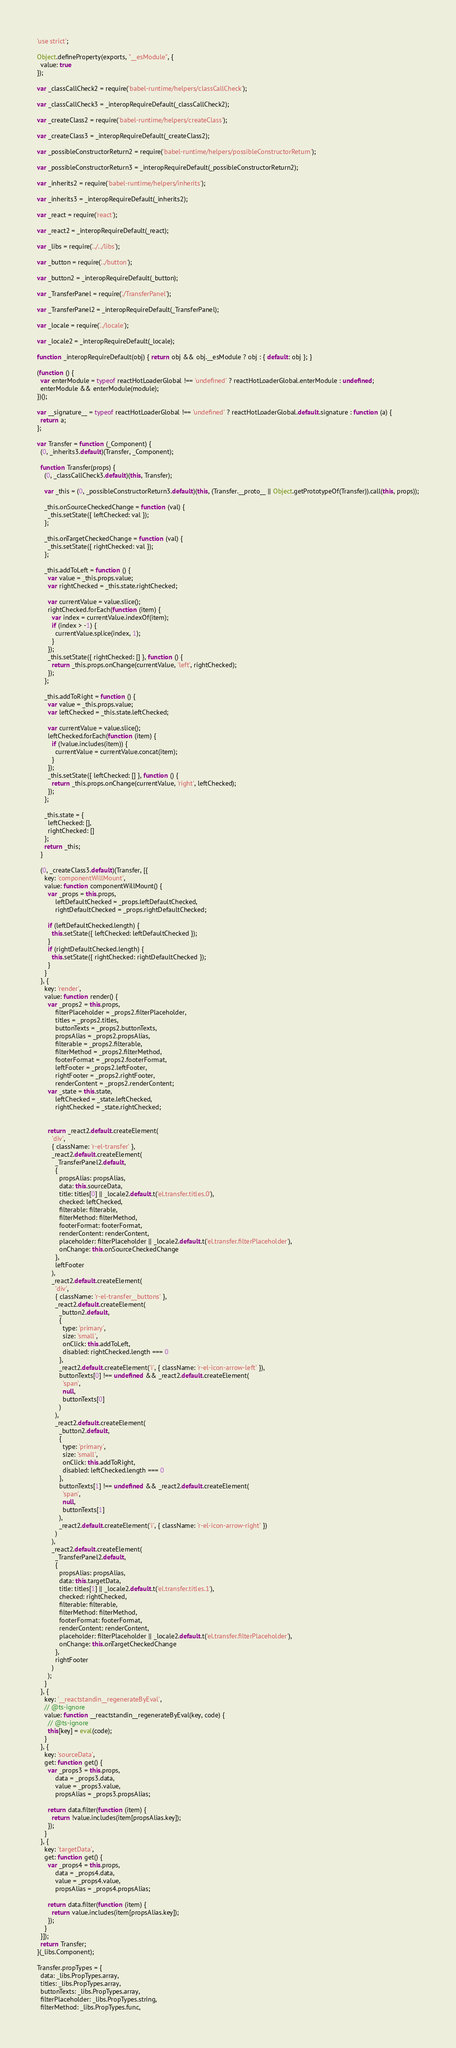<code> <loc_0><loc_0><loc_500><loc_500><_JavaScript_>'use strict';

Object.defineProperty(exports, "__esModule", {
  value: true
});

var _classCallCheck2 = require('babel-runtime/helpers/classCallCheck');

var _classCallCheck3 = _interopRequireDefault(_classCallCheck2);

var _createClass2 = require('babel-runtime/helpers/createClass');

var _createClass3 = _interopRequireDefault(_createClass2);

var _possibleConstructorReturn2 = require('babel-runtime/helpers/possibleConstructorReturn');

var _possibleConstructorReturn3 = _interopRequireDefault(_possibleConstructorReturn2);

var _inherits2 = require('babel-runtime/helpers/inherits');

var _inherits3 = _interopRequireDefault(_inherits2);

var _react = require('react');

var _react2 = _interopRequireDefault(_react);

var _libs = require('../../libs');

var _button = require('../button');

var _button2 = _interopRequireDefault(_button);

var _TransferPanel = require('./TransferPanel');

var _TransferPanel2 = _interopRequireDefault(_TransferPanel);

var _locale = require('../locale');

var _locale2 = _interopRequireDefault(_locale);

function _interopRequireDefault(obj) { return obj && obj.__esModule ? obj : { default: obj }; }

(function () {
  var enterModule = typeof reactHotLoaderGlobal !== 'undefined' ? reactHotLoaderGlobal.enterModule : undefined;
  enterModule && enterModule(module);
})();

var __signature__ = typeof reactHotLoaderGlobal !== 'undefined' ? reactHotLoaderGlobal.default.signature : function (a) {
  return a;
};

var Transfer = function (_Component) {
  (0, _inherits3.default)(Transfer, _Component);

  function Transfer(props) {
    (0, _classCallCheck3.default)(this, Transfer);

    var _this = (0, _possibleConstructorReturn3.default)(this, (Transfer.__proto__ || Object.getPrototypeOf(Transfer)).call(this, props));

    _this.onSourceCheckedChange = function (val) {
      _this.setState({ leftChecked: val });
    };

    _this.onTargetCheckedChange = function (val) {
      _this.setState({ rightChecked: val });
    };

    _this.addToLeft = function () {
      var value = _this.props.value;
      var rightChecked = _this.state.rightChecked;

      var currentValue = value.slice();
      rightChecked.forEach(function (item) {
        var index = currentValue.indexOf(item);
        if (index > -1) {
          currentValue.splice(index, 1);
        }
      });
      _this.setState({ rightChecked: [] }, function () {
        return _this.props.onChange(currentValue, 'left', rightChecked);
      });
    };

    _this.addToRight = function () {
      var value = _this.props.value;
      var leftChecked = _this.state.leftChecked;

      var currentValue = value.slice();
      leftChecked.forEach(function (item) {
        if (!value.includes(item)) {
          currentValue = currentValue.concat(item);
        }
      });
      _this.setState({ leftChecked: [] }, function () {
        return _this.props.onChange(currentValue, 'right', leftChecked);
      });
    };

    _this.state = {
      leftChecked: [],
      rightChecked: []
    };
    return _this;
  }

  (0, _createClass3.default)(Transfer, [{
    key: 'componentWillMount',
    value: function componentWillMount() {
      var _props = this.props,
          leftDefaultChecked = _props.leftDefaultChecked,
          rightDefaultChecked = _props.rightDefaultChecked;

      if (leftDefaultChecked.length) {
        this.setState({ leftChecked: leftDefaultChecked });
      }
      if (rightDefaultChecked.length) {
        this.setState({ rightChecked: rightDefaultChecked });
      }
    }
  }, {
    key: 'render',
    value: function render() {
      var _props2 = this.props,
          filterPlaceholder = _props2.filterPlaceholder,
          titles = _props2.titles,
          buttonTexts = _props2.buttonTexts,
          propsAlias = _props2.propsAlias,
          filterable = _props2.filterable,
          filterMethod = _props2.filterMethod,
          footerFormat = _props2.footerFormat,
          leftFooter = _props2.leftFooter,
          rightFooter = _props2.rightFooter,
          renderContent = _props2.renderContent;
      var _state = this.state,
          leftChecked = _state.leftChecked,
          rightChecked = _state.rightChecked;


      return _react2.default.createElement(
        'div',
        { className: 'r-el-transfer' },
        _react2.default.createElement(
          _TransferPanel2.default,
          {
            propsAlias: propsAlias,
            data: this.sourceData,
            title: titles[0] || _locale2.default.t('el.transfer.titles.0'),
            checked: leftChecked,
            filterable: filterable,
            filterMethod: filterMethod,
            footerFormat: footerFormat,
            renderContent: renderContent,
            placeholder: filterPlaceholder || _locale2.default.t('el.transfer.filterPlaceholder'),
            onChange: this.onSourceCheckedChange
          },
          leftFooter
        ),
        _react2.default.createElement(
          'div',
          { className: 'r-el-transfer__buttons' },
          _react2.default.createElement(
            _button2.default,
            {
              type: 'primary',
              size: 'small',
              onClick: this.addToLeft,
              disabled: rightChecked.length === 0
            },
            _react2.default.createElement('i', { className: 'r-el-icon-arrow-left' }),
            buttonTexts[0] !== undefined && _react2.default.createElement(
              'span',
              null,
              buttonTexts[0]
            )
          ),
          _react2.default.createElement(
            _button2.default,
            {
              type: 'primary',
              size: 'small',
              onClick: this.addToRight,
              disabled: leftChecked.length === 0
            },
            buttonTexts[1] !== undefined && _react2.default.createElement(
              'span',
              null,
              buttonTexts[1]
            ),
            _react2.default.createElement('i', { className: 'r-el-icon-arrow-right' })
          )
        ),
        _react2.default.createElement(
          _TransferPanel2.default,
          {
            propsAlias: propsAlias,
            data: this.targetData,
            title: titles[1] || _locale2.default.t('el.transfer.titles.1'),
            checked: rightChecked,
            filterable: filterable,
            filterMethod: filterMethod,
            footerFormat: footerFormat,
            renderContent: renderContent,
            placeholder: filterPlaceholder || _locale2.default.t('el.transfer.filterPlaceholder'),
            onChange: this.onTargetCheckedChange
          },
          rightFooter
        )
      );
    }
  }, {
    key: '__reactstandin__regenerateByEval',
    // @ts-ignore
    value: function __reactstandin__regenerateByEval(key, code) {
      // @ts-ignore
      this[key] = eval(code);
    }
  }, {
    key: 'sourceData',
    get: function get() {
      var _props3 = this.props,
          data = _props3.data,
          value = _props3.value,
          propsAlias = _props3.propsAlias;

      return data.filter(function (item) {
        return !value.includes(item[propsAlias.key]);
      });
    }
  }, {
    key: 'targetData',
    get: function get() {
      var _props4 = this.props,
          data = _props4.data,
          value = _props4.value,
          propsAlias = _props4.propsAlias;

      return data.filter(function (item) {
        return value.includes(item[propsAlias.key]);
      });
    }
  }]);
  return Transfer;
}(_libs.Component);

Transfer.propTypes = {
  data: _libs.PropTypes.array,
  titles: _libs.PropTypes.array,
  buttonTexts: _libs.PropTypes.array,
  filterPlaceholder: _libs.PropTypes.string,
  filterMethod: _libs.PropTypes.func,</code> 